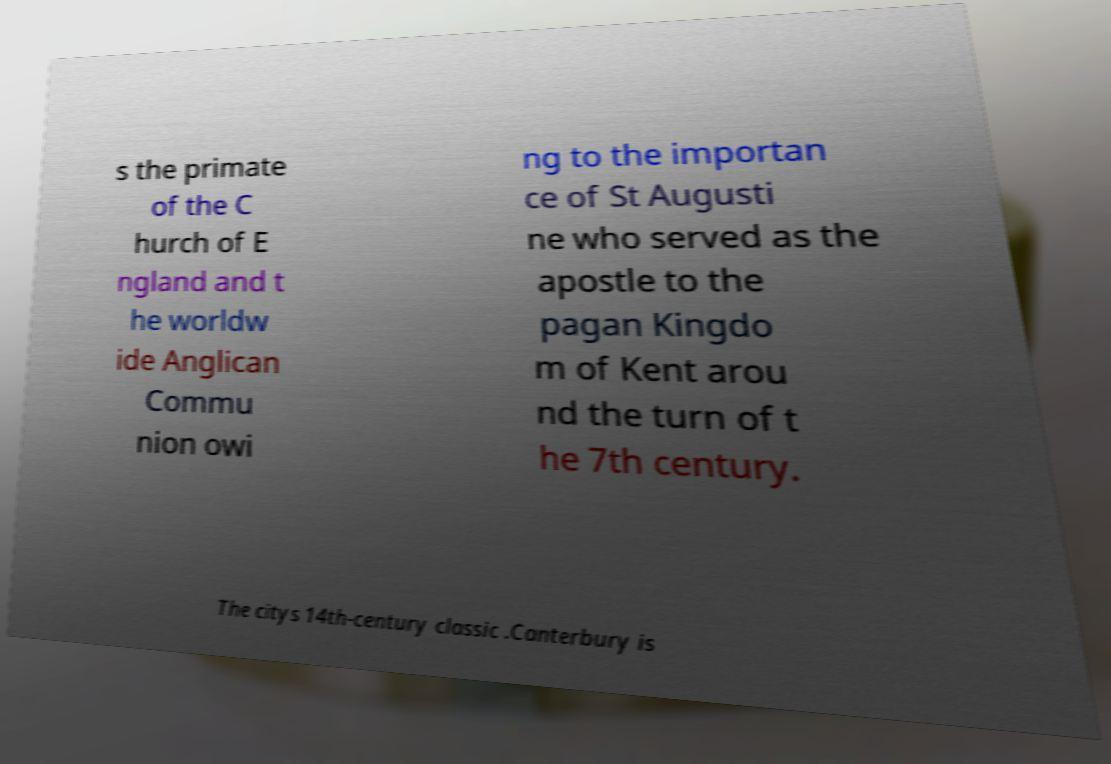Can you accurately transcribe the text from the provided image for me? s the primate of the C hurch of E ngland and t he worldw ide Anglican Commu nion owi ng to the importan ce of St Augusti ne who served as the apostle to the pagan Kingdo m of Kent arou nd the turn of t he 7th century. The citys 14th-century classic .Canterbury is 